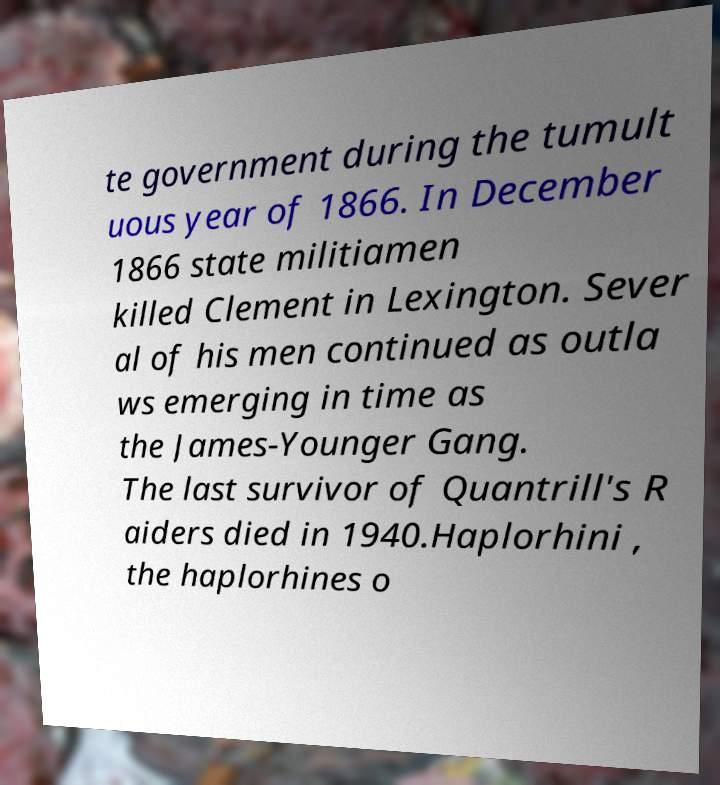Can you read and provide the text displayed in the image?This photo seems to have some interesting text. Can you extract and type it out for me? te government during the tumult uous year of 1866. In December 1866 state militiamen killed Clement in Lexington. Sever al of his men continued as outla ws emerging in time as the James-Younger Gang. The last survivor of Quantrill's R aiders died in 1940.Haplorhini , the haplorhines o 